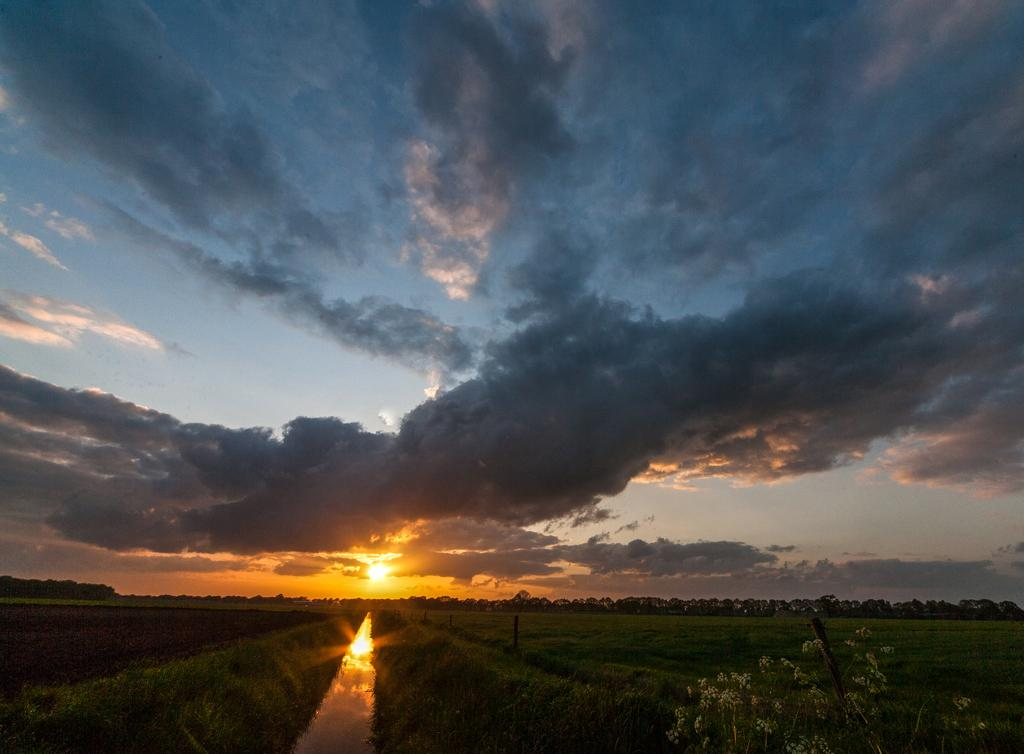What type of location is depicted in the image? There is an agricultural farm in the image. What type of vegetation can be seen on the farm? Grass is present on the farm. Is there any water visible on the farm? Yes, there is water on the surface of the farm. What is the position of the sun in the image? The sun is setting at the top of the image. What can be seen in the sky in the image? There are clouds in the sky. Where is the family room located on the farm? There is no family room mentioned or visible in the image; it is an agricultural farm with no specific rooms. What type of stocking is hanging from the clouds in the image? There are no stockings visible in the image; only clouds and the setting sun are present in the sky. 